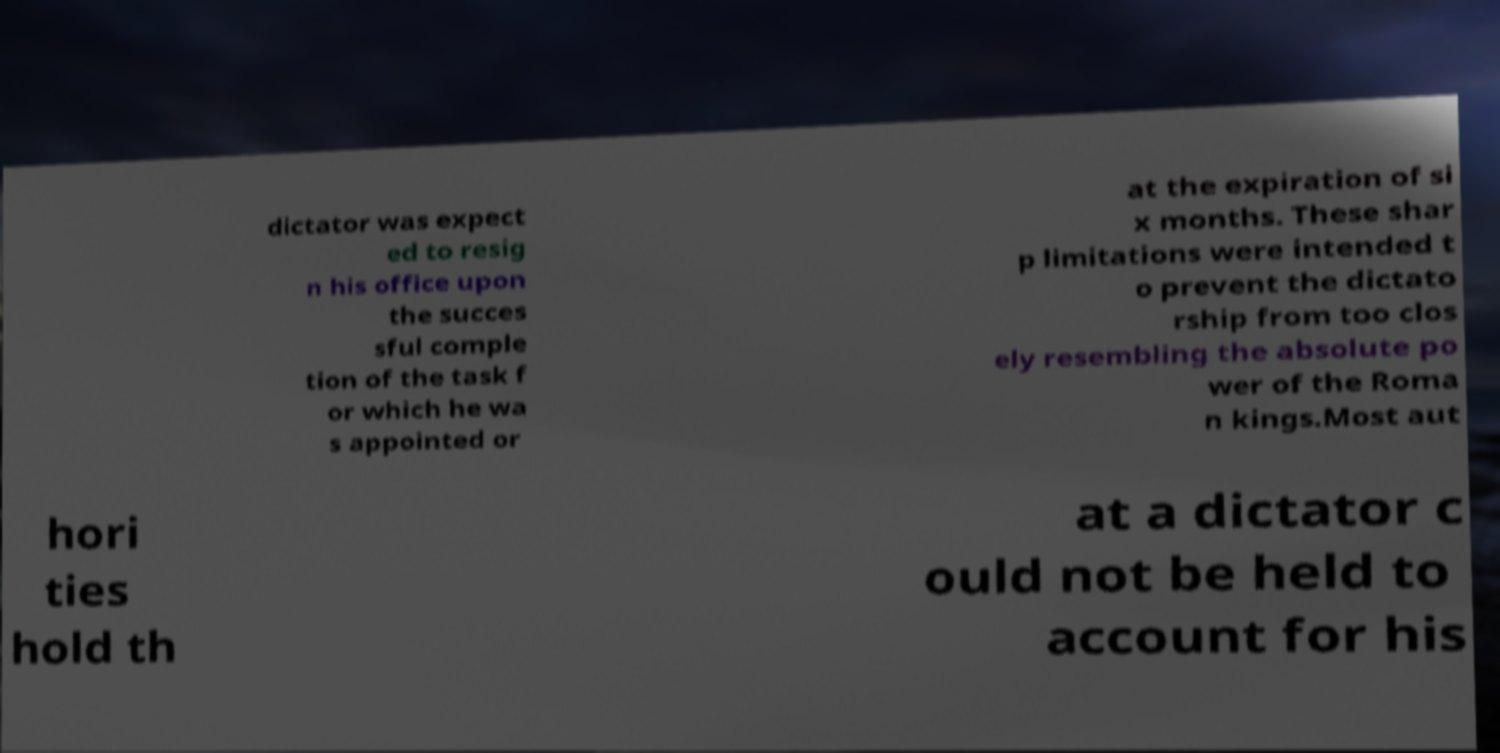There's text embedded in this image that I need extracted. Can you transcribe it verbatim? dictator was expect ed to resig n his office upon the succes sful comple tion of the task f or which he wa s appointed or at the expiration of si x months. These shar p limitations were intended t o prevent the dictato rship from too clos ely resembling the absolute po wer of the Roma n kings.Most aut hori ties hold th at a dictator c ould not be held to account for his 